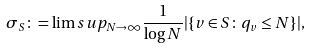<formula> <loc_0><loc_0><loc_500><loc_500>\sigma _ { S } \colon = \lim s u p _ { N \to \infty } \frac { 1 } { \log N } | \{ v \in S \colon \, q _ { v } \leq N \} | ,</formula> 